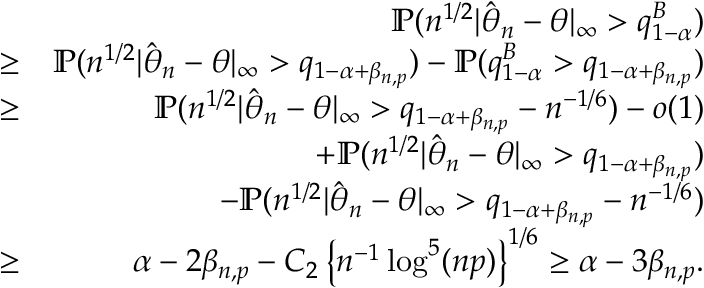<formula> <loc_0><loc_0><loc_500><loc_500>\begin{array} { r l r } & { { \mathbb { P } } ( n ^ { 1 / 2 } | \hat { \boldsymbol \theta } _ { n } - { \boldsymbol \theta } | _ { \infty } > q _ { 1 - \alpha } ^ { B } ) } \\ & { \geq } & { { \mathbb { P } } ( n ^ { 1 / 2 } | \hat { \boldsymbol \theta } _ { n } - { \boldsymbol \theta } | _ { \infty } > q _ { 1 - \alpha + \beta _ { n , p } } ) - { \mathbb { P } } ( q _ { 1 - \alpha } ^ { B } > q _ { 1 - \alpha + \beta _ { n , p } } ) } \\ & { \geq } & { { \mathbb { P } } ( n ^ { 1 / 2 } | \hat { \boldsymbol \theta } _ { n } - { \boldsymbol \theta } | _ { \infty } > q _ { 1 - \alpha + \beta _ { n , p } } - n ^ { - 1 / 6 } ) - o ( 1 ) } \\ & { + { \mathbb { P } } ( n ^ { 1 / 2 } | \hat { \boldsymbol \theta } _ { n } - { \boldsymbol \theta } | _ { \infty } > q _ { 1 - \alpha + \beta _ { n , p } } ) } \\ & { - { \mathbb { P } } ( n ^ { 1 / 2 } | \hat { \boldsymbol \theta } _ { n } - { \boldsymbol \theta } | _ { \infty } > q _ { 1 - \alpha + \beta _ { n , p } } - n ^ { - 1 / 6 } ) } \\ & { \geq } & { \alpha - 2 \beta _ { n , p } - C _ { 2 } \left \{ n ^ { - 1 } \log ^ { 5 } ( n p ) \right \} ^ { 1 / 6 } \geq \alpha - 3 \beta _ { n , p } . } \end{array}</formula> 